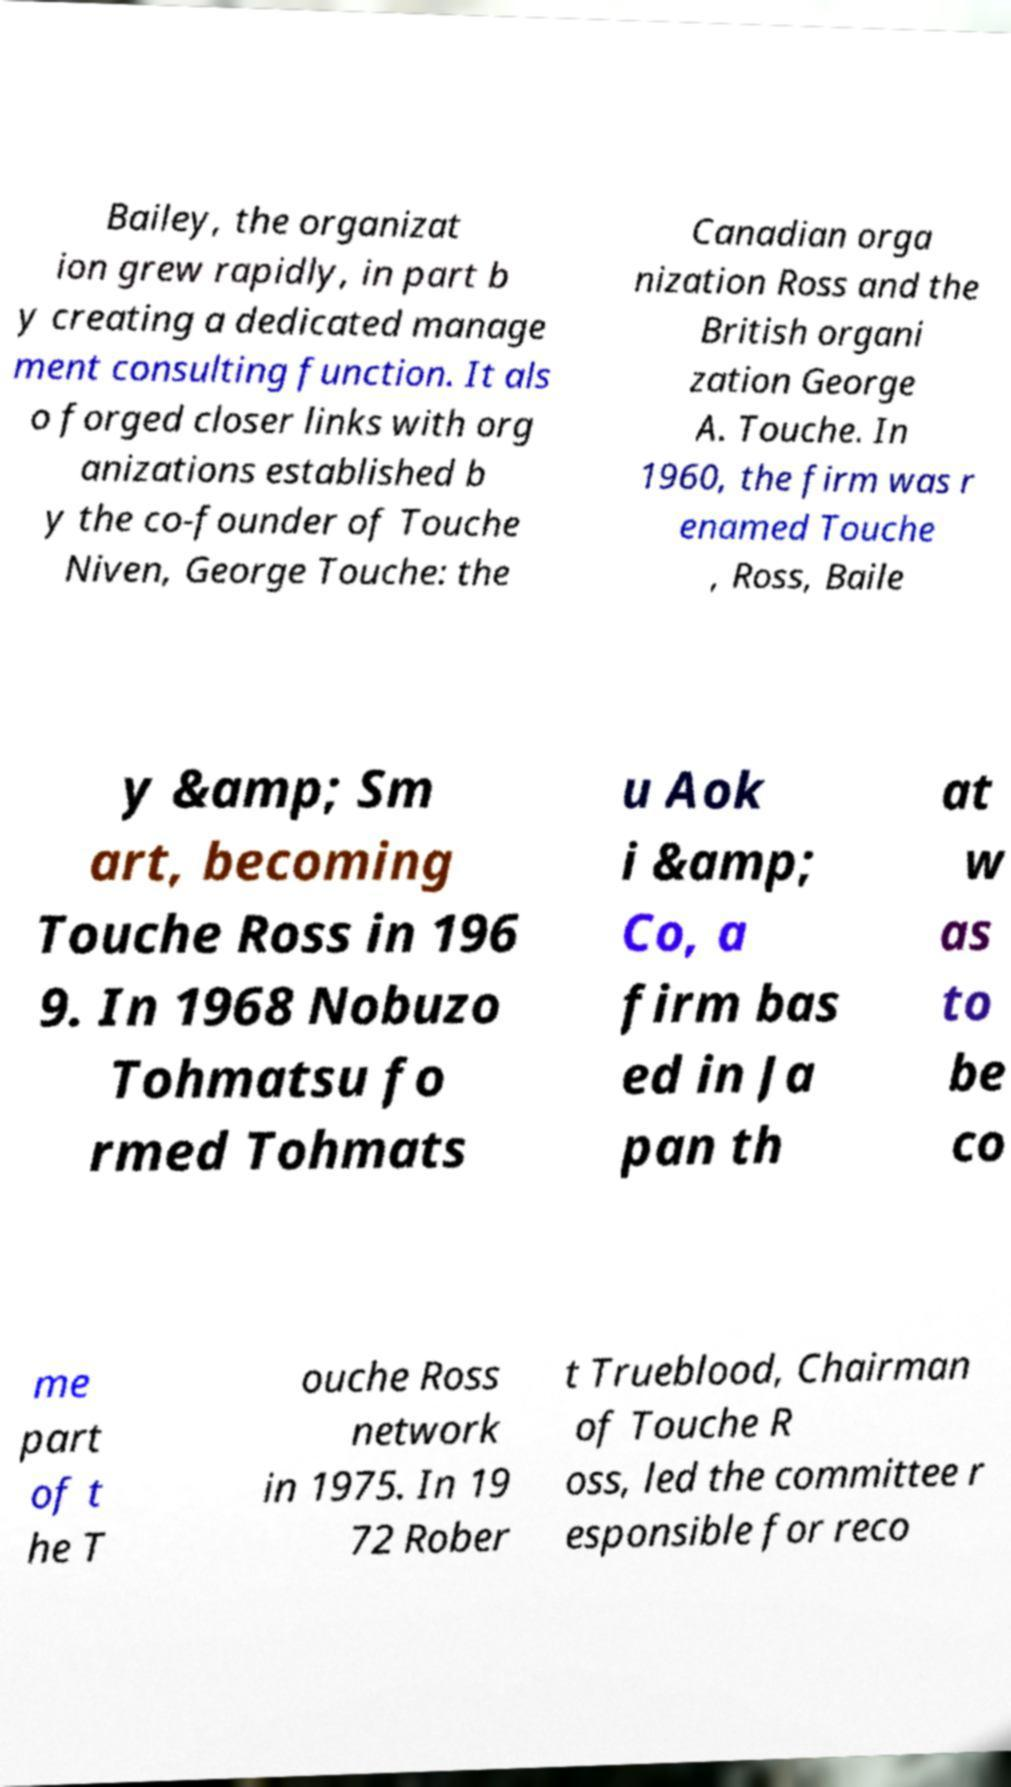Can you read and provide the text displayed in the image?This photo seems to have some interesting text. Can you extract and type it out for me? Bailey, the organizat ion grew rapidly, in part b y creating a dedicated manage ment consulting function. It als o forged closer links with org anizations established b y the co-founder of Touche Niven, George Touche: the Canadian orga nization Ross and the British organi zation George A. Touche. In 1960, the firm was r enamed Touche , Ross, Baile y &amp; Sm art, becoming Touche Ross in 196 9. In 1968 Nobuzo Tohmatsu fo rmed Tohmats u Aok i &amp; Co, a firm bas ed in Ja pan th at w as to be co me part of t he T ouche Ross network in 1975. In 19 72 Rober t Trueblood, Chairman of Touche R oss, led the committee r esponsible for reco 